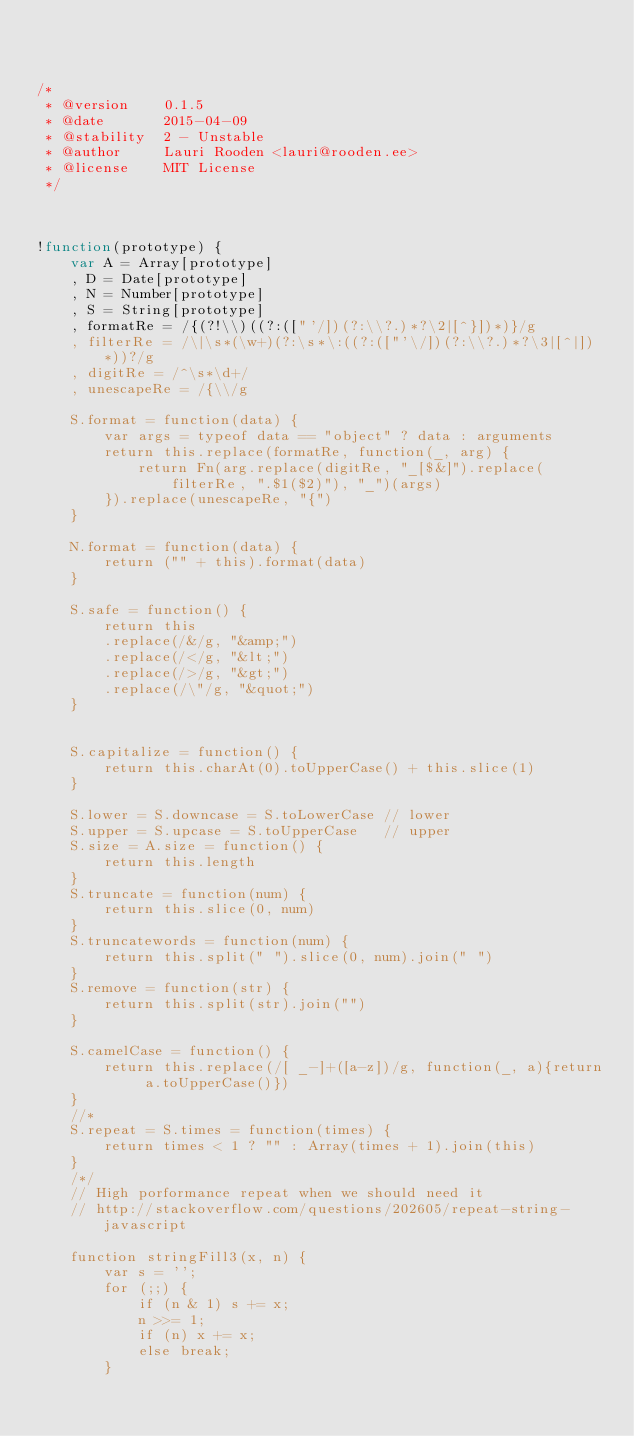Convert code to text. <code><loc_0><loc_0><loc_500><loc_500><_JavaScript_>


/*
 * @version    0.1.5
 * @date       2015-04-09
 * @stability  2 - Unstable
 * @author     Lauri Rooden <lauri@rooden.ee>
 * @license    MIT License
 */



!function(prototype) {
	var A = Array[prototype]
	, D = Date[prototype]
	, N = Number[prototype]
	, S = String[prototype]
	, formatRe = /{(?!\\)((?:(["'/])(?:\\?.)*?\2|[^}])*)}/g
	, filterRe = /\|\s*(\w+)(?:\s*\:((?:(["'\/])(?:\\?.)*?\3|[^|])*))?/g
	, digitRe = /^\s*\d+/
	, unescapeRe = /{\\/g

	S.format = function(data) {
		var args = typeof data == "object" ? data : arguments
		return this.replace(formatRe, function(_, arg) {
			return Fn(arg.replace(digitRe, "_[$&]").replace(filterRe, ".$1($2)"), "_")(args)
		}).replace(unescapeRe, "{")
	}

	N.format = function(data) {
		return ("" + this).format(data)
	}

	S.safe = function() {
		return this
		.replace(/&/g, "&amp;")
		.replace(/</g, "&lt;")
		.replace(/>/g, "&gt;")
		.replace(/\"/g, "&quot;")
	}


	S.capitalize = function() {
		return this.charAt(0).toUpperCase() + this.slice(1)
	}

	S.lower = S.downcase = S.toLowerCase // lower
	S.upper = S.upcase = S.toUpperCase   // upper
	S.size = A.size = function() {
		return this.length
	}
	S.truncate = function(num) {
		return this.slice(0, num)
	}
	S.truncatewords = function(num) {
		return this.split(" ").slice(0, num).join(" ")
	}
	S.remove = function(str) {
		return this.split(str).join("")
	}

	S.camelCase = function() {
		return this.replace(/[ _-]+([a-z])/g, function(_, a){return a.toUpperCase()})
	}
	//*
	S.repeat = S.times = function(times) {
		return times < 1 ? "" : Array(times + 1).join(this)
	}
	/*/
	// High porformance repeat when we should need it
	// http://stackoverflow.com/questions/202605/repeat-string-javascript

	function stringFill3(x, n) {
		var s = '';
		for (;;) {
			if (n & 1) s += x;
			n >>= 1;
			if (n) x += x;
			else break;
		}</code> 